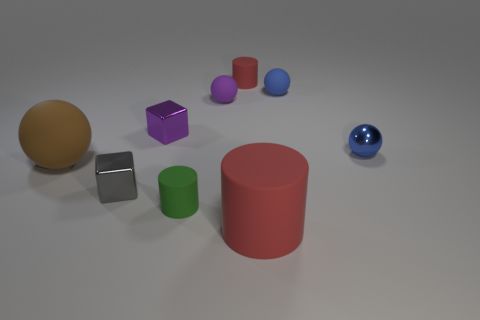There is a small cylinder right of the small green thing; does it have the same color as the large matte cylinder?
Your answer should be compact. Yes. What number of things are either tiny cyan metal spheres or tiny metal objects that are in front of the blue shiny ball?
Make the answer very short. 1. What is the tiny object that is in front of the tiny blue metal object and behind the tiny green cylinder made of?
Your response must be concise. Metal. There is a blue thing that is behind the tiny blue shiny thing; what material is it?
Give a very brief answer. Rubber. What color is the other small block that is the same material as the gray block?
Keep it short and to the point. Purple. There is a big brown object; does it have the same shape as the tiny blue thing that is behind the purple cube?
Your response must be concise. Yes. Are there any objects in front of the purple shiny block?
Offer a terse response. Yes. What material is the object that is the same color as the large cylinder?
Make the answer very short. Rubber. Is the size of the gray object the same as the rubber ball that is left of the tiny green rubber object?
Offer a terse response. No. Is there a small object that has the same color as the metallic sphere?
Your response must be concise. Yes. 